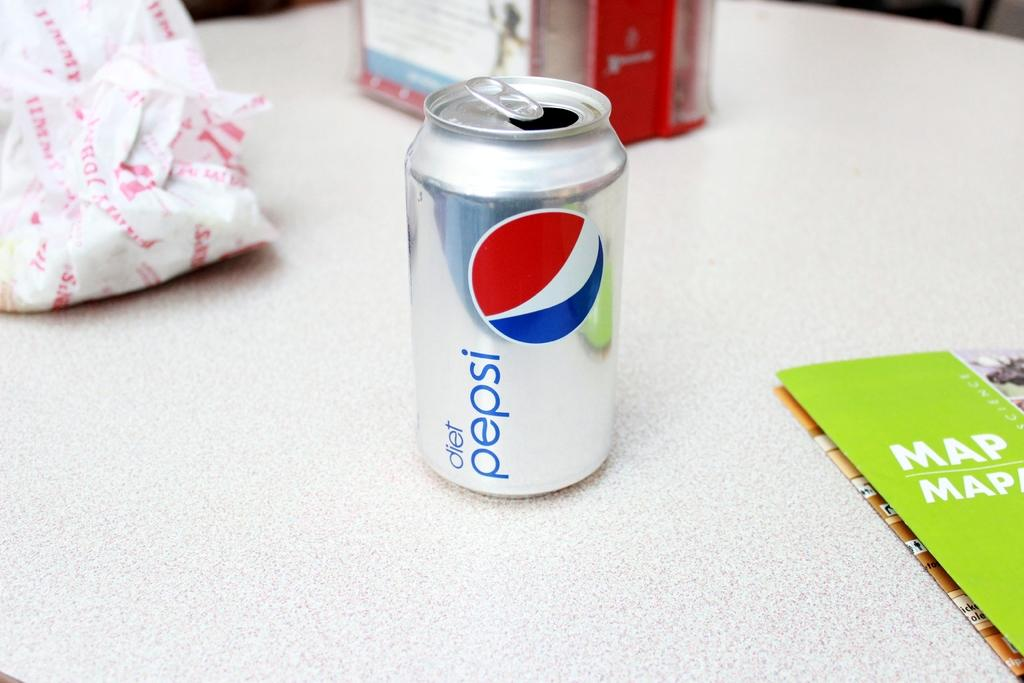Provide a one-sentence caption for the provided image. An open can of Diet Pepsi is on a table next to a map and a Jimmy John sandwich wrapper. 